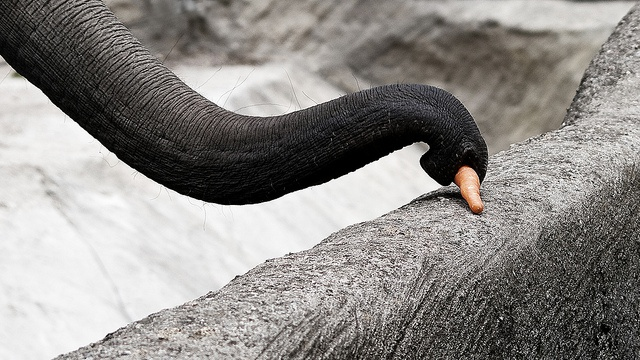Describe the objects in this image and their specific colors. I can see elephant in gray, black, and darkgray tones and carrot in black, tan, and lightgray tones in this image. 